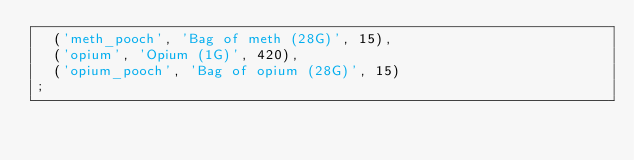<code> <loc_0><loc_0><loc_500><loc_500><_SQL_>	('meth_pooch', 'Bag of meth (28G)', 15),
	('opium', 'Opium (1G)', 420),
	('opium_pooch', 'Bag of opium (28G)', 15)
;
</code> 